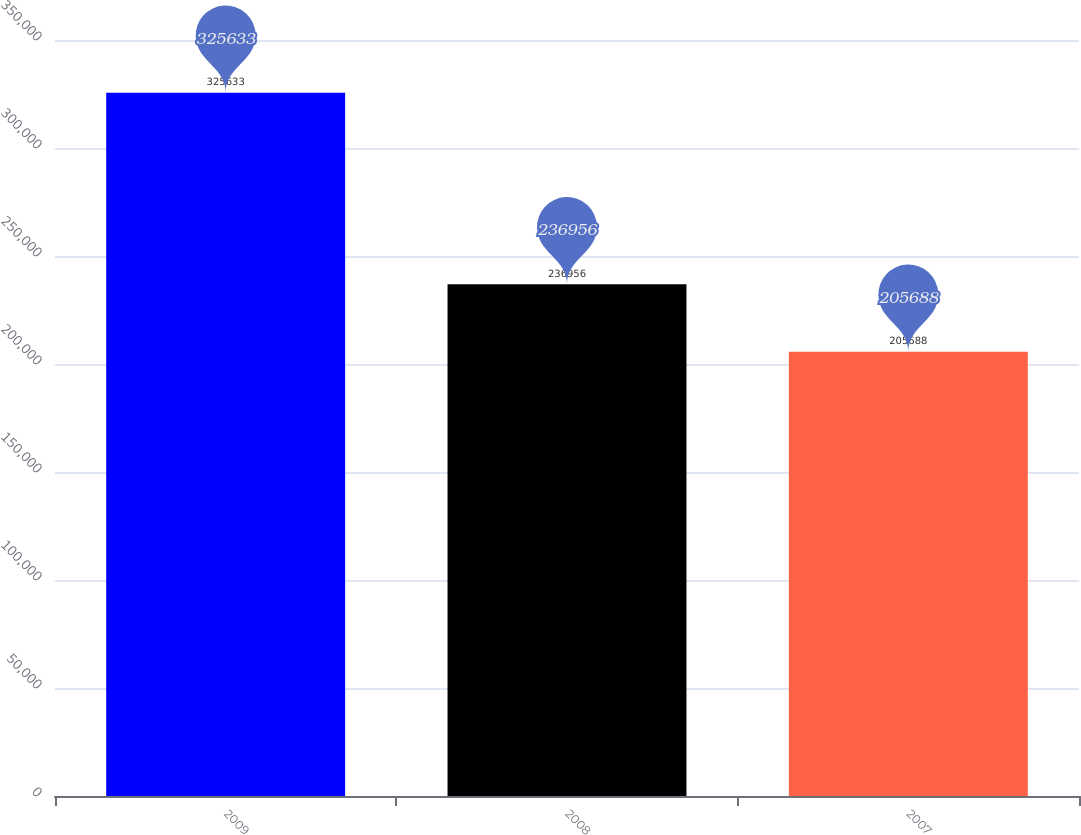Convert chart to OTSL. <chart><loc_0><loc_0><loc_500><loc_500><bar_chart><fcel>2009<fcel>2008<fcel>2007<nl><fcel>325633<fcel>236956<fcel>205688<nl></chart> 